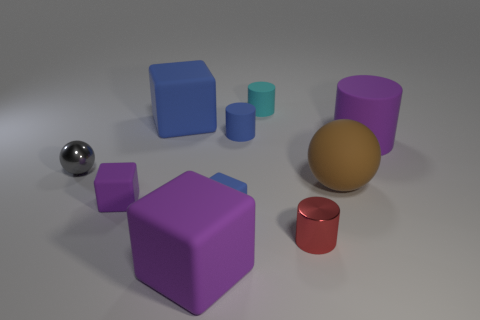Subtract 1 blocks. How many blocks are left? 3 Subtract all cubes. How many objects are left? 6 Add 8 gray objects. How many gray objects are left? 9 Add 4 large brown rubber cylinders. How many large brown rubber cylinders exist? 4 Subtract 0 yellow balls. How many objects are left? 10 Subtract all matte blocks. Subtract all small gray shiny spheres. How many objects are left? 5 